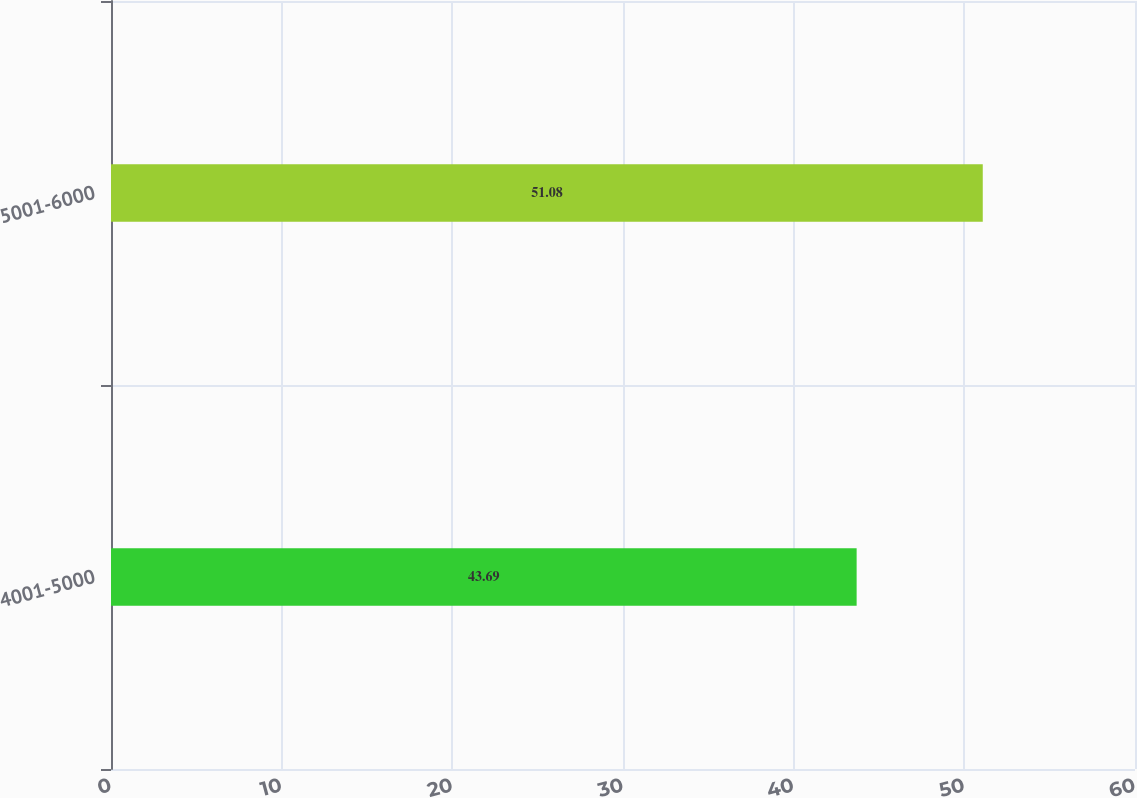Convert chart. <chart><loc_0><loc_0><loc_500><loc_500><bar_chart><fcel>4001-5000<fcel>5001-6000<nl><fcel>43.69<fcel>51.08<nl></chart> 